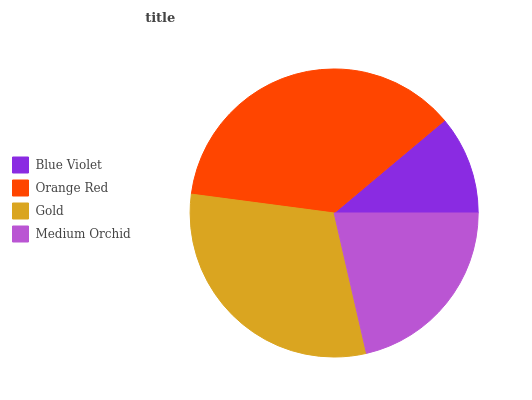Is Blue Violet the minimum?
Answer yes or no. Yes. Is Orange Red the maximum?
Answer yes or no. Yes. Is Gold the minimum?
Answer yes or no. No. Is Gold the maximum?
Answer yes or no. No. Is Orange Red greater than Gold?
Answer yes or no. Yes. Is Gold less than Orange Red?
Answer yes or no. Yes. Is Gold greater than Orange Red?
Answer yes or no. No. Is Orange Red less than Gold?
Answer yes or no. No. Is Gold the high median?
Answer yes or no. Yes. Is Medium Orchid the low median?
Answer yes or no. Yes. Is Blue Violet the high median?
Answer yes or no. No. Is Orange Red the low median?
Answer yes or no. No. 